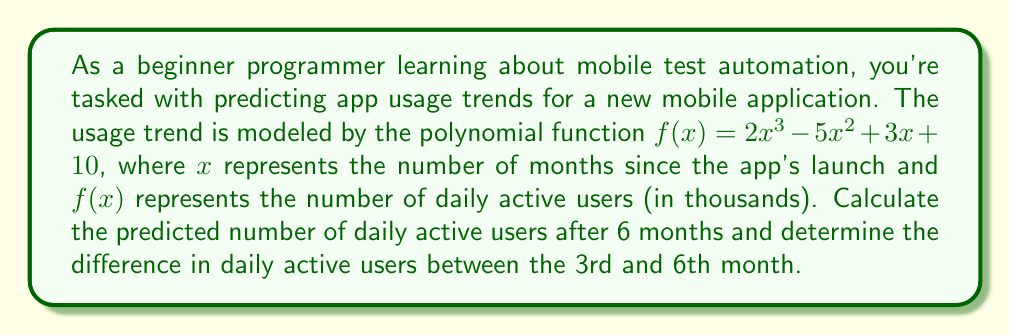Teach me how to tackle this problem. To solve this problem, we need to evaluate the polynomial function at specific x values. Let's break it down step-by-step:

1. Given polynomial function: $f(x) = 2x^3 - 5x^2 + 3x + 10$

2. To find the number of daily active users after 6 months, we evaluate $f(6)$:
   $f(6) = 2(6^3) - 5(6^2) + 3(6) + 10$
   $= 2(216) - 5(36) + 3(6) + 10$
   $= 432 - 180 + 18 + 10$
   $= 280$

   So, after 6 months, the predicted number of daily active users is 280,000.

3. To find the number of daily active users after 3 months, we evaluate $f(3)$:
   $f(3) = 2(3^3) - 5(3^2) + 3(3) + 10$
   $= 2(27) - 5(9) + 3(3) + 10$
   $= 54 - 45 + 9 + 10$
   $= 28$

   So, after 3 months, the predicted number of daily active users is 28,000.

4. To determine the difference in daily active users between the 3rd and 6th month:
   Difference = $f(6) - f(3) = 280 - 28 = 252$

Therefore, the difference in daily active users between the 3rd and 6th month is 252,000.
Answer: The predicted number of daily active users after 6 months is 280,000, and the difference in daily active users between the 3rd and 6th month is 252,000. 